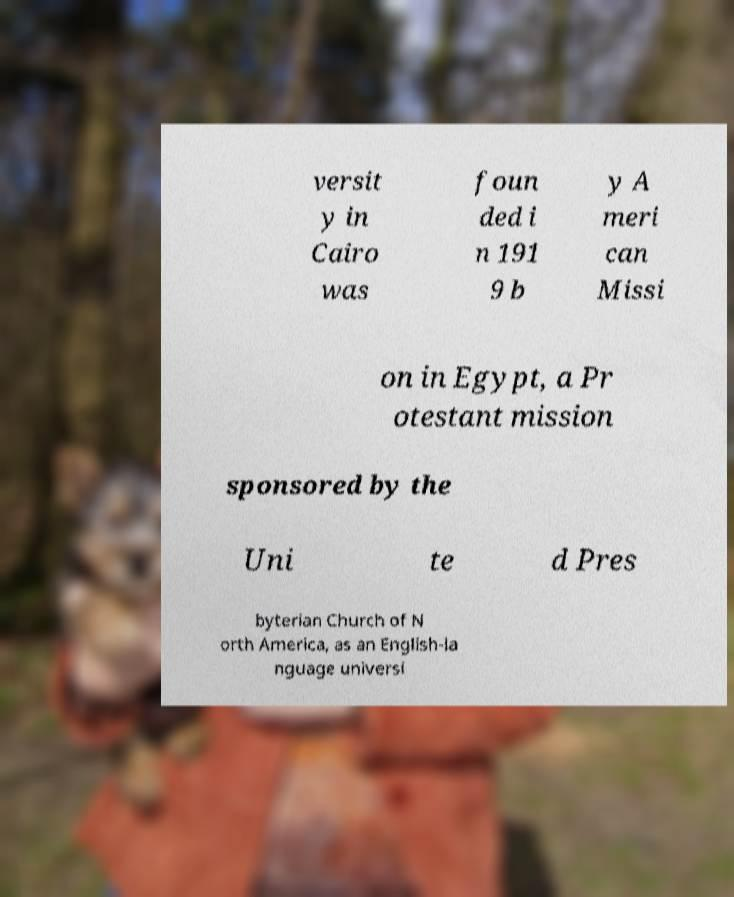Could you assist in decoding the text presented in this image and type it out clearly? versit y in Cairo was foun ded i n 191 9 b y A meri can Missi on in Egypt, a Pr otestant mission sponsored by the Uni te d Pres byterian Church of N orth America, as an English-la nguage universi 